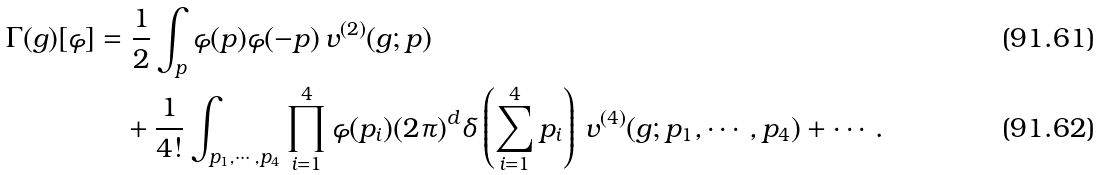<formula> <loc_0><loc_0><loc_500><loc_500>\Gamma ( g ) [ \varphi ] & = \frac { 1 } { 2 } \int _ { p } \varphi ( p ) \varphi ( - p ) \, v ^ { ( 2 ) } ( g ; p ) \\ & \quad + \frac { 1 } { 4 ! } \int _ { p _ { 1 } , \cdots , p _ { 4 } } \prod _ { i = 1 } ^ { 4 } \varphi ( p _ { i } ) ( 2 \pi ) ^ { d } \delta \left ( \sum _ { i = 1 } ^ { 4 } p _ { i } \right ) \, v ^ { ( 4 ) } ( g ; p _ { 1 } , \cdots , p _ { 4 } ) + \cdots \, .</formula> 